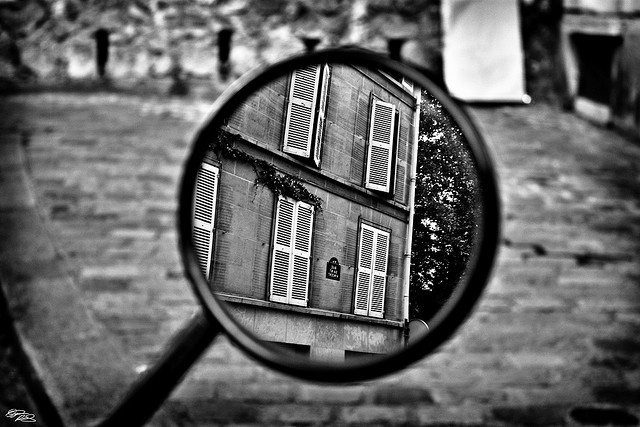Describe the objects in this image and their specific colors. I can see various objects in this image with different colors. 